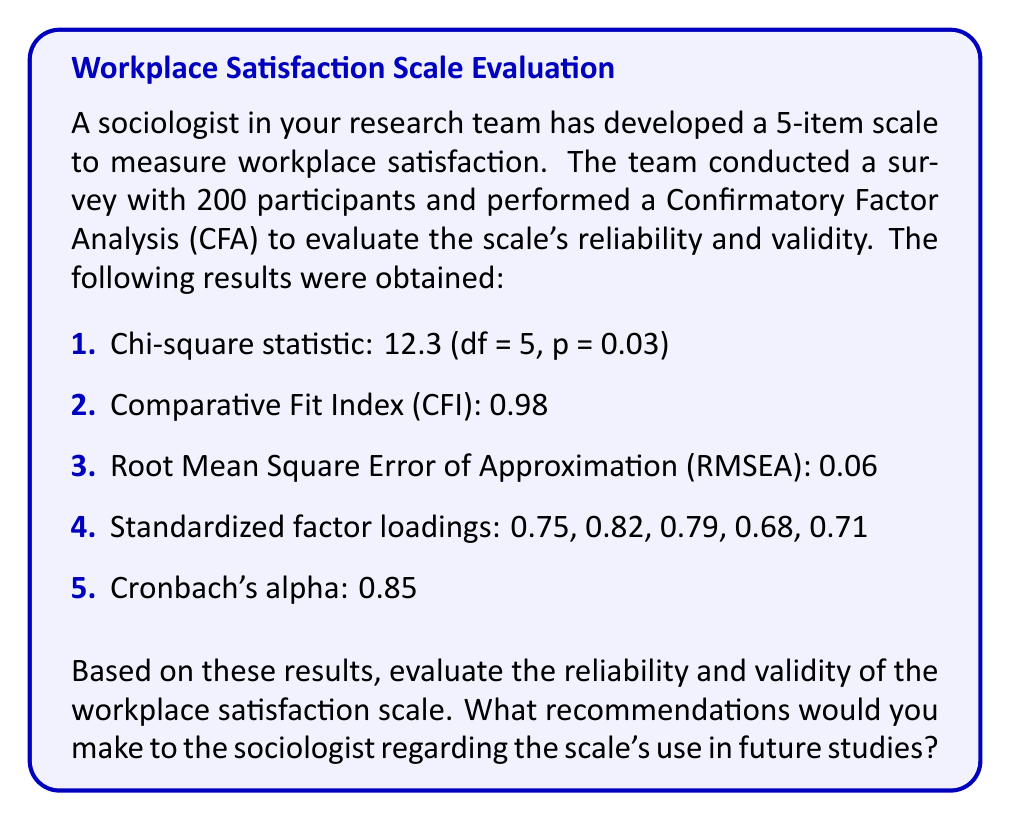Give your solution to this math problem. To evaluate the reliability and validity of the workplace satisfaction scale, we need to examine each of the provided statistics:

1. Chi-square statistic:
The chi-square test assesses the overall fit of the model. A non-significant p-value (p > 0.05) indicates a good fit. In this case, $\chi^2 = 12.3$ with df = 5 and p = 0.03. The p-value is less than 0.05, suggesting that the model fit is not ideal.

2. Comparative Fit Index (CFI):
The CFI compares the fit of the proposed model to a null model. Values above 0.95 indicate a good fit. Here, CFI = 0.98, which suggests excellent fit.

3. Root Mean Square Error of Approximation (RMSEA):
The RMSEA estimates the lack of fit in a model compared to a perfect model. Values below 0.08 indicate acceptable fit, while values below 0.05 indicate good fit. Here, RMSEA = 0.06, suggesting an acceptable fit.

4. Standardized factor loadings:
Factor loadings represent the correlation between each item and the latent construct. Values above 0.7 are considered good, while those above 0.6 are acceptable. The loadings (0.75, 0.82, 0.79, 0.68, 0.71) are all above 0.6, with four out of five above 0.7, indicating good convergent validity.

5. Cronbach's alpha:
Cronbach's alpha measures internal consistency reliability. Values above 0.7 are considered acceptable, while those above 0.8 are good. Here, $\alpha = 0.85$, indicating good internal consistency reliability.

Reliability:
The scale demonstrates good reliability based on the Cronbach's alpha value of 0.85.

Validity:
- Construct validity: The CFA results (CFI and RMSEA) suggest acceptable to good construct validity.
- Convergent validity: The factor loadings indicate good convergent validity.

Recommendations:
1. The scale generally demonstrates good reliability and validity, making it suitable for use in future studies.
2. Consider refining the model to improve the chi-square statistic, possibly by examining modification indices or reassessing the theoretical structure.
3. Pay attention to the item with the lowest factor loading (0.68) and consider revising or replacing it if theoretical considerations allow.
4. Conduct additional validity tests, such as discriminant validity and criterion-related validity, to further establish the scale's psychometric properties.
5. Cross-validate the scale with different samples to ensure its generalizability.
Answer: The workplace satisfaction scale demonstrates good reliability ($\alpha = 0.85$) and acceptable to good validity (CFI = 0.98, RMSEA = 0.06, factor loadings > 0.6). While suitable for use in future studies, minor refinements could improve its psychometric properties, particularly addressing the chi-square statistic (p = 0.03) and the lowest factor loading (0.68). 